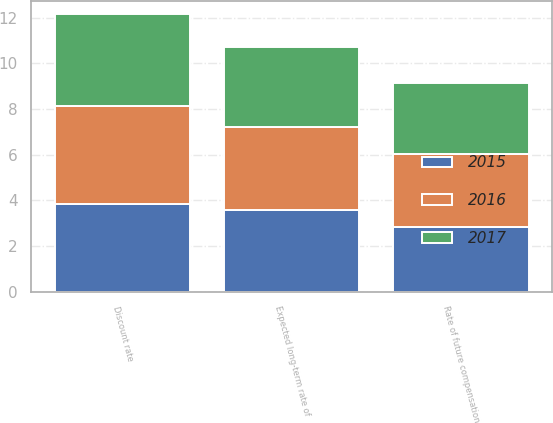<chart> <loc_0><loc_0><loc_500><loc_500><stacked_bar_chart><ecel><fcel>Discount rate<fcel>Expected long-term rate of<fcel>Rate of future compensation<nl><fcel>2017<fcel>4.01<fcel>3.52<fcel>3.1<nl><fcel>2016<fcel>4.27<fcel>3.61<fcel>3.19<nl><fcel>2015<fcel>3.86<fcel>3.59<fcel>2.85<nl></chart> 